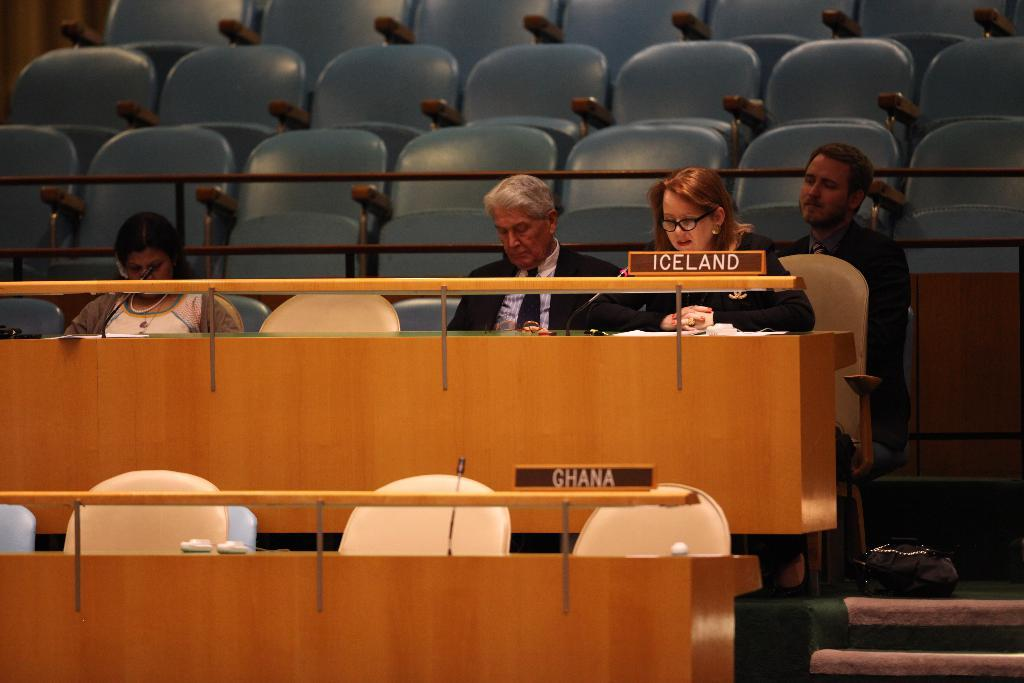<image>
Create a compact narrative representing the image presented. Representatives for Iceland sit in at a meeting 